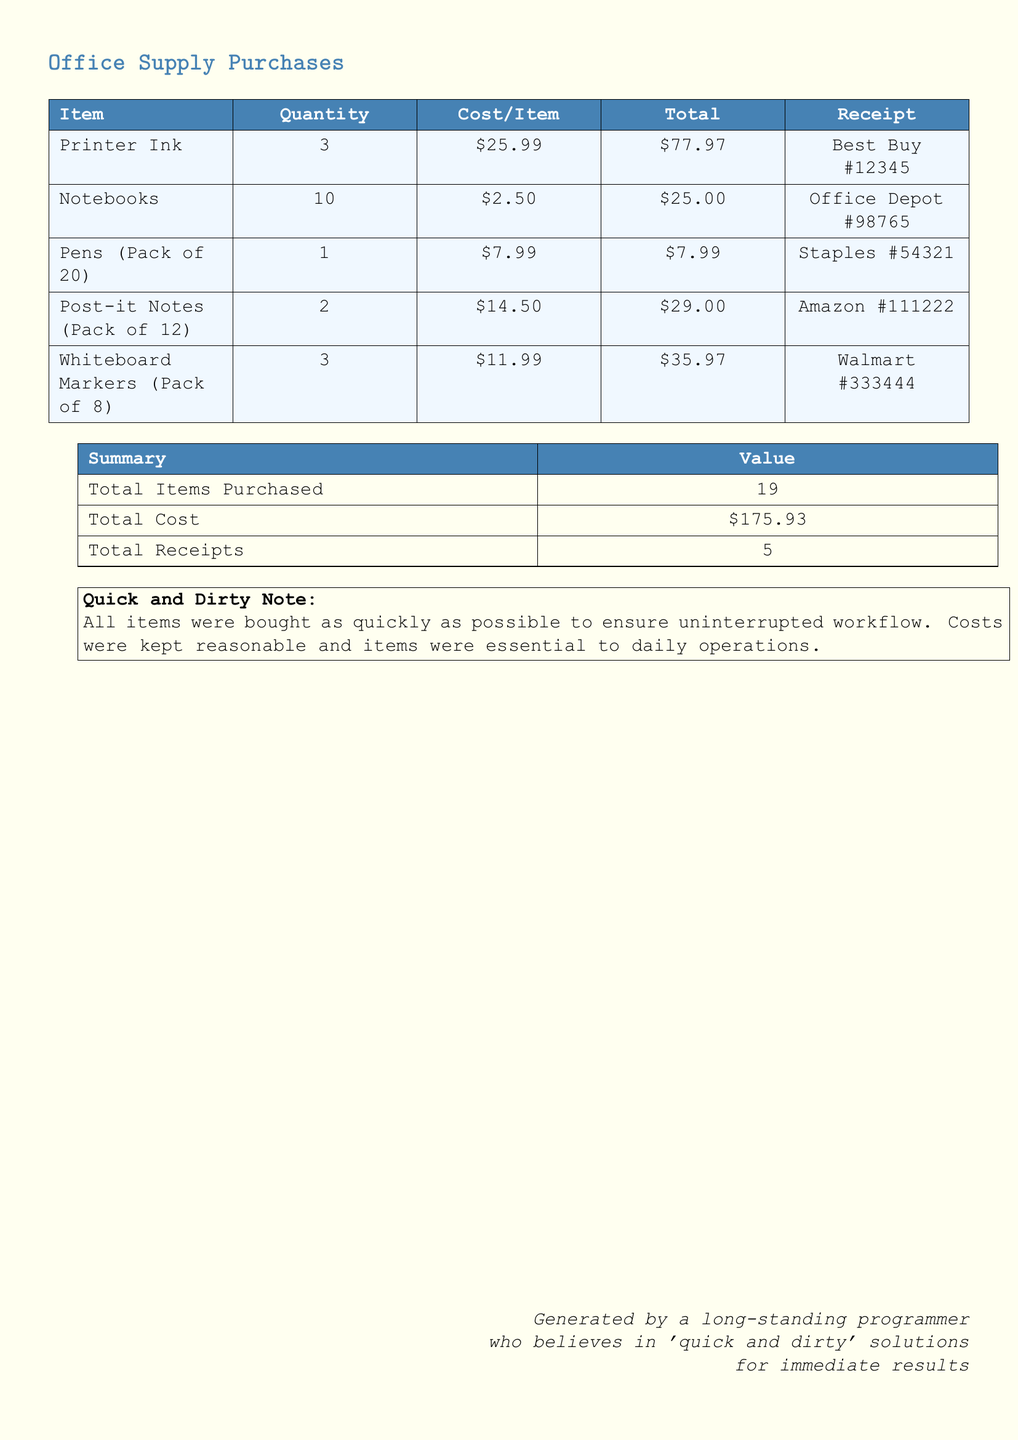What is the total cost? The total cost is calculated from the sum of all individual item totals in the document, which adds up to $175.93.
Answer: $175.93 How many items were purchased? The number of items purchased is the sum of all quantities listed in the document, which totals to 19.
Answer: 19 What is the receipt number for Printer Ink? The receipt number for Printer Ink can be found in the related row, which is Best Buy #12345.
Answer: Best Buy #12345 How many receipts were submitted? The number of receipts is provided in the summary section of the document, which states there are 5 receipts in total.
Answer: 5 What is the cost per item for Notebooks? The cost per item for Notebooks is clearly mentioned in the table, which is $2.50.
Answer: $2.50 What is the total for Whiteboard Markers? The total cost for Whiteboard Markers can be determined from the table where it is stated as $35.97.
Answer: $35.97 What item has the highest individual cost? By examining the costs per item in the table, the item with the highest individual cost is Printer Ink at $25.99.
Answer: Printer Ink How many total packs of Post-it Notes were purchased? The quantity for Post-it Notes in the document is 2 packs.
Answer: 2 What was the primary reason for these purchases? The document has a note stating that purchases were made quickly to ensure uninterrupted workflow.
Answer: Uninterrupted workflow 